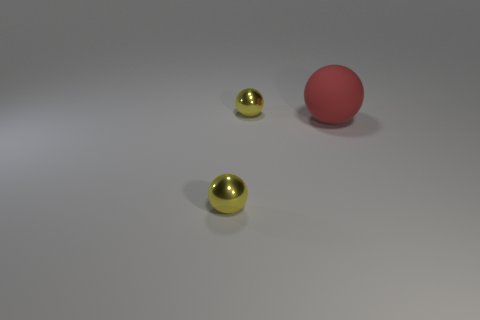Are there any other things that have the same size as the red ball?
Provide a short and direct response. No. Is the number of large red objects greater than the number of blue spheres?
Ensure brevity in your answer.  Yes. What number of other red objects are the same material as the big object?
Provide a succinct answer. 0. How many objects are tiny yellow things in front of the big red thing or yellow metal objects behind the matte sphere?
Offer a very short reply. 2. The object that is behind the big thing is what color?
Your answer should be compact. Yellow. Is there another yellow thing that has the same shape as the large rubber object?
Make the answer very short. Yes. What number of gray things are either balls or tiny metal things?
Your answer should be compact. 0. Are there any green cylinders that have the same size as the red matte sphere?
Keep it short and to the point. No. What number of tiny metallic spheres are there?
Your response must be concise. 2. What number of large objects are shiny spheres or cyan matte things?
Keep it short and to the point. 0. 